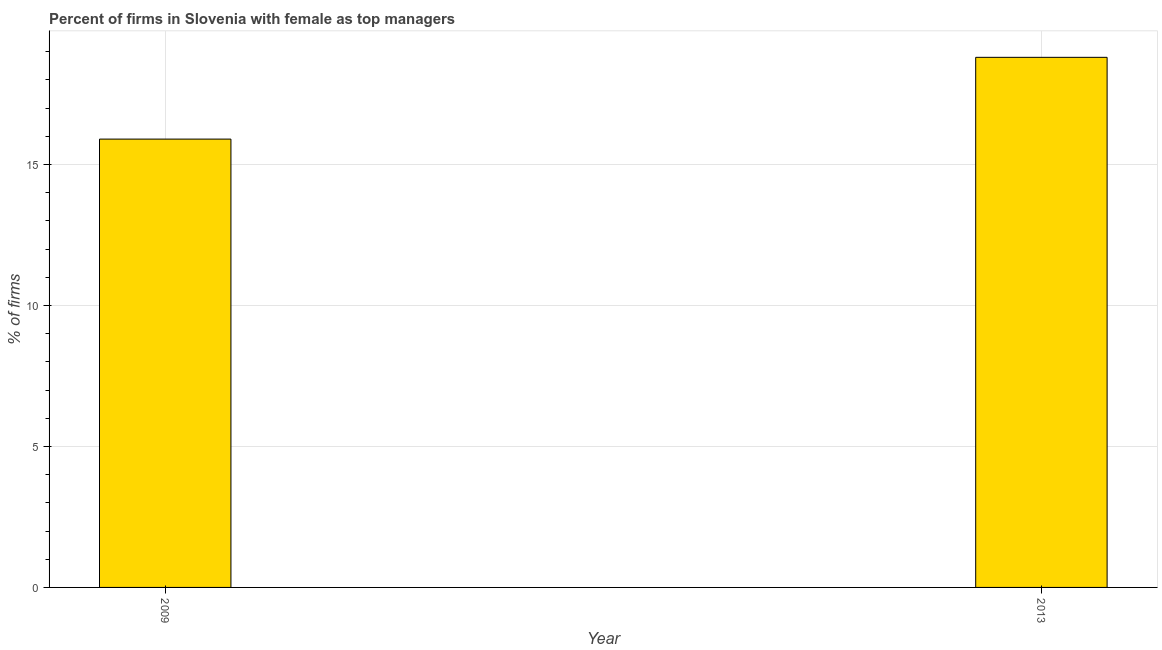Does the graph contain grids?
Provide a short and direct response. Yes. What is the title of the graph?
Keep it short and to the point. Percent of firms in Slovenia with female as top managers. What is the label or title of the X-axis?
Keep it short and to the point. Year. What is the label or title of the Y-axis?
Offer a very short reply. % of firms. What is the percentage of firms with female as top manager in 2009?
Ensure brevity in your answer.  15.9. Across all years, what is the maximum percentage of firms with female as top manager?
Offer a very short reply. 18.8. What is the sum of the percentage of firms with female as top manager?
Your answer should be compact. 34.7. What is the difference between the percentage of firms with female as top manager in 2009 and 2013?
Offer a terse response. -2.9. What is the average percentage of firms with female as top manager per year?
Ensure brevity in your answer.  17.35. What is the median percentage of firms with female as top manager?
Provide a succinct answer. 17.35. In how many years, is the percentage of firms with female as top manager greater than 3 %?
Your answer should be compact. 2. Do a majority of the years between 2009 and 2013 (inclusive) have percentage of firms with female as top manager greater than 11 %?
Provide a short and direct response. Yes. What is the ratio of the percentage of firms with female as top manager in 2009 to that in 2013?
Give a very brief answer. 0.85. What is the difference between two consecutive major ticks on the Y-axis?
Your answer should be compact. 5. Are the values on the major ticks of Y-axis written in scientific E-notation?
Keep it short and to the point. No. What is the % of firms of 2013?
Your answer should be very brief. 18.8. What is the difference between the % of firms in 2009 and 2013?
Offer a very short reply. -2.9. What is the ratio of the % of firms in 2009 to that in 2013?
Give a very brief answer. 0.85. 